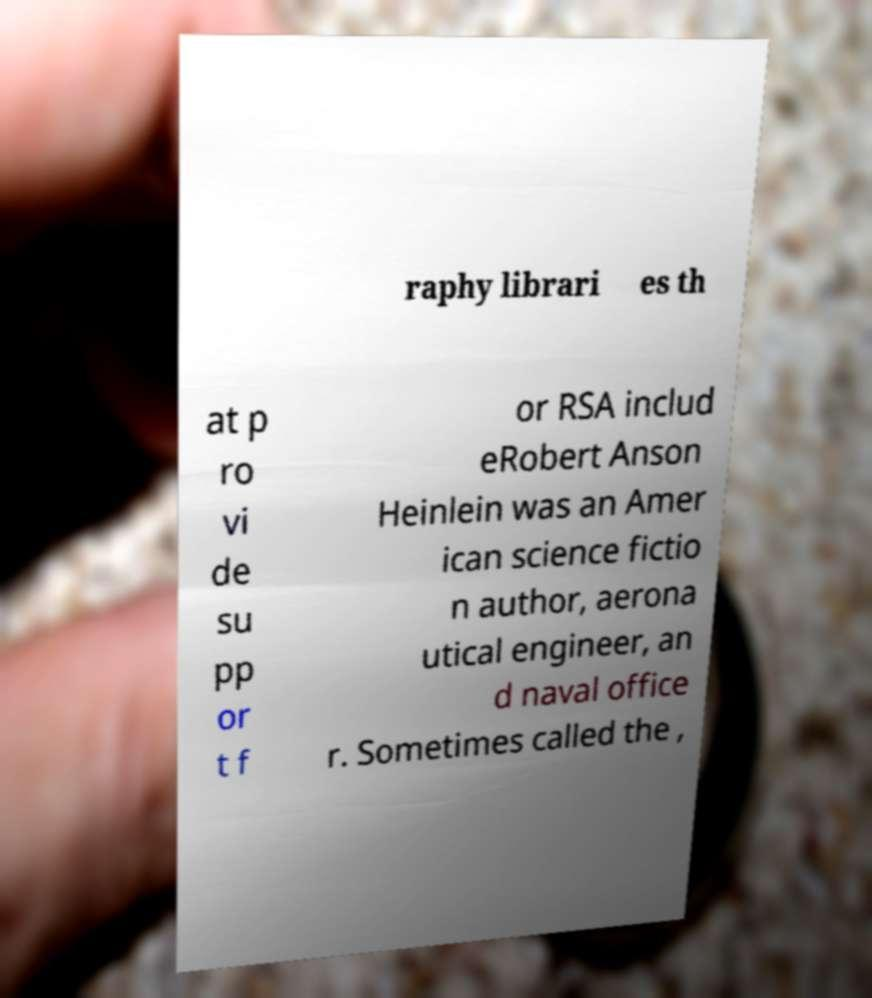There's text embedded in this image that I need extracted. Can you transcribe it verbatim? raphy librari es th at p ro vi de su pp or t f or RSA includ eRobert Anson Heinlein was an Amer ican science fictio n author, aerona utical engineer, an d naval office r. Sometimes called the , 